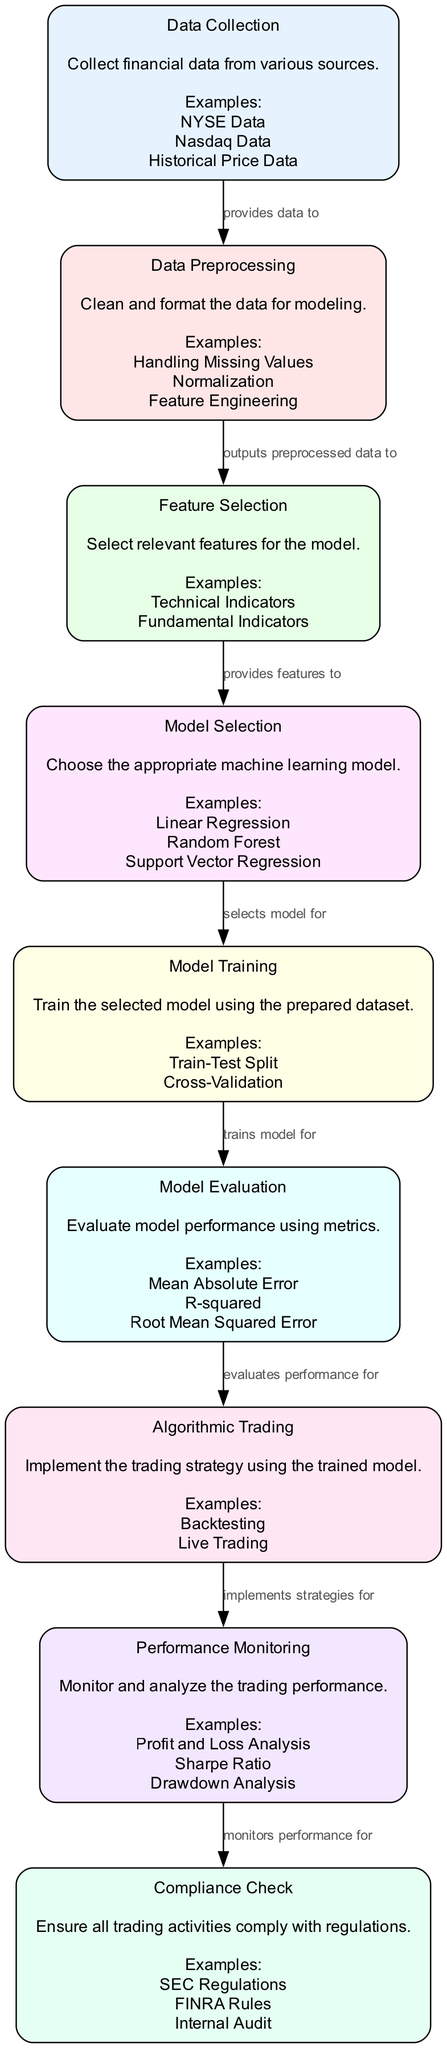What is the first step in the diagram? The diagram begins with the "Data Collection" node, which indicates the initial step of gathering financial data from various sources.
Answer: Data Collection How many nodes are present in the diagram? Upon counting all the nodes in the diagram, there are a total of 9 nodes that represent different stages of the algorithmic trading strategy performance analysis process.
Answer: 9 What is the relationship between "ModelEvaluation" and "AlgorithmicTrading"? The "ModelEvaluation" node evaluates the model's performance, which is then used in the "AlgorithmicTrading" node to implement the trading strategy based on that evaluation.
Answer: evaluates performance for Which node follows "FeatureSelection"? After "FeatureSelection," the next node is "ModelSelection," where the procedure involves choosing the appropriate machine learning model based on the selected features.
Answer: Model Selection What are the examples listed under the "Compliance Check" node? The "Compliance Check" node lists examples such as SEC Regulations, FINRA Rules, and Internal Audit as part of the process to ensure compliance with trading regulations.
Answer: SEC Regulations, FINRA Rules, Internal Audit What is the last step in the diagram? The final step in the diagram is the "Compliance Check," ensuring that all trading activities adhere to regulatory standards.
Answer: Compliance Check How does "Performance Monitoring" relate to "Algorithmic Trading"? The "Performance Monitoring" node analyzes the outcomes of the "Algorithmic Trading" strategies to assess their effectiveness and make necessary adjustments.
Answer: monitors performance for What type of features are selected in "FeatureSelection"? In the "FeatureSelection" node, the relevant features selected include both Technical Indicators and Fundamental Indicators, which are critical for the model.
Answer: Technical Indicators, Fundamental Indicators What is the function of the "Data Preprocessing" node? The "Data Preprocessing" node's function is to clean and format the financial data, making it suitable for modeling by performing tasks such as handling missing values and normalization.
Answer: Clean and format the data for modeling 